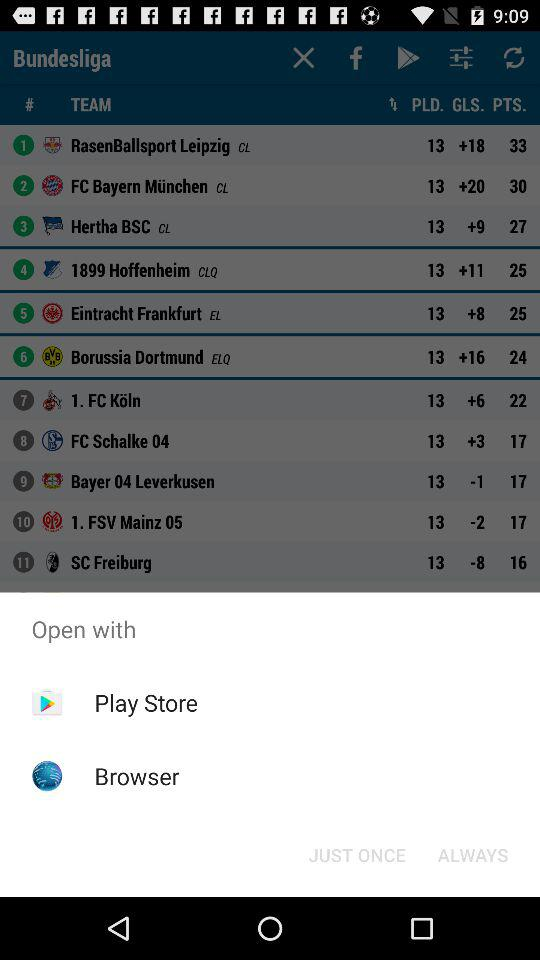How many teams have a positive goal difference?
Answer the question using a single word or phrase. 8 